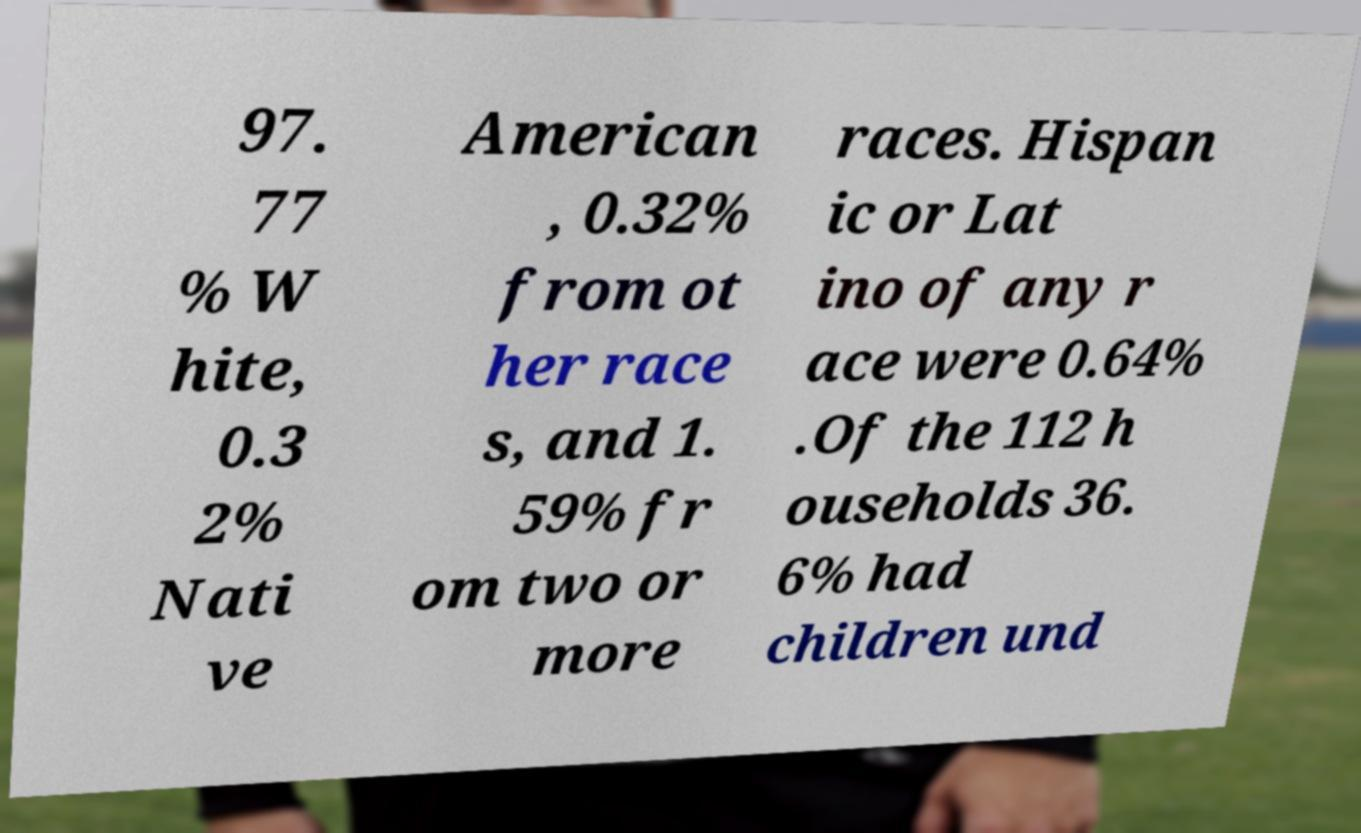Can you read and provide the text displayed in the image?This photo seems to have some interesting text. Can you extract and type it out for me? 97. 77 % W hite, 0.3 2% Nati ve American , 0.32% from ot her race s, and 1. 59% fr om two or more races. Hispan ic or Lat ino of any r ace were 0.64% .Of the 112 h ouseholds 36. 6% had children und 